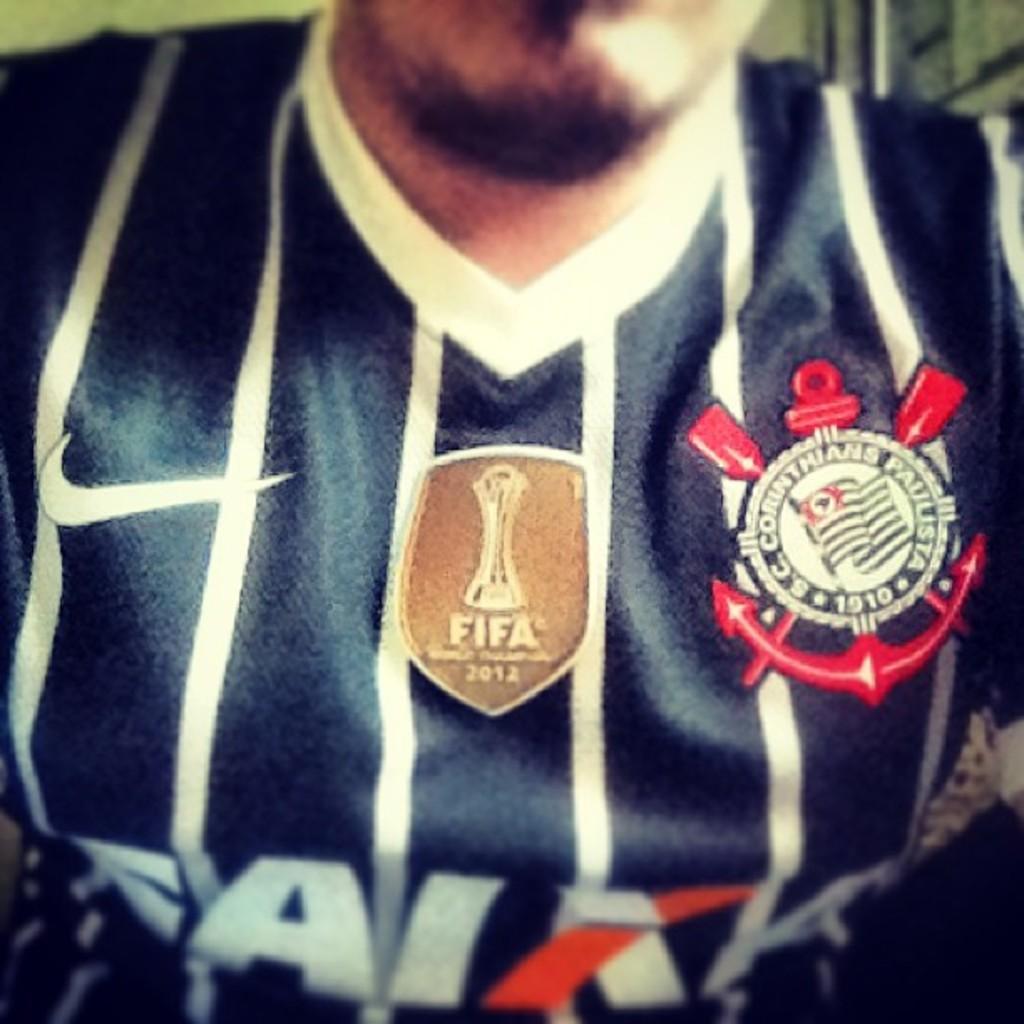Is there a gold fifa tag on his shirt?
Your answer should be very brief. Yes. What year is the gold fifa tag from?
Offer a terse response. 2012. 